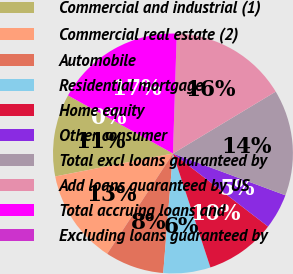<chart> <loc_0><loc_0><loc_500><loc_500><pie_chart><fcel>Commercial and industrial (1)<fcel>Commercial real estate (2)<fcel>Automobile<fcel>Residential mortgage<fcel>Home equity<fcel>Other consumer<fcel>Total excl loans guaranteed by<fcel>Add loans guaranteed by US<fcel>Total accruing loans and<fcel>Excluding loans guaranteed by<nl><fcel>11.11%<fcel>12.7%<fcel>7.94%<fcel>6.35%<fcel>9.52%<fcel>4.76%<fcel>14.29%<fcel>15.87%<fcel>17.46%<fcel>0.0%<nl></chart> 